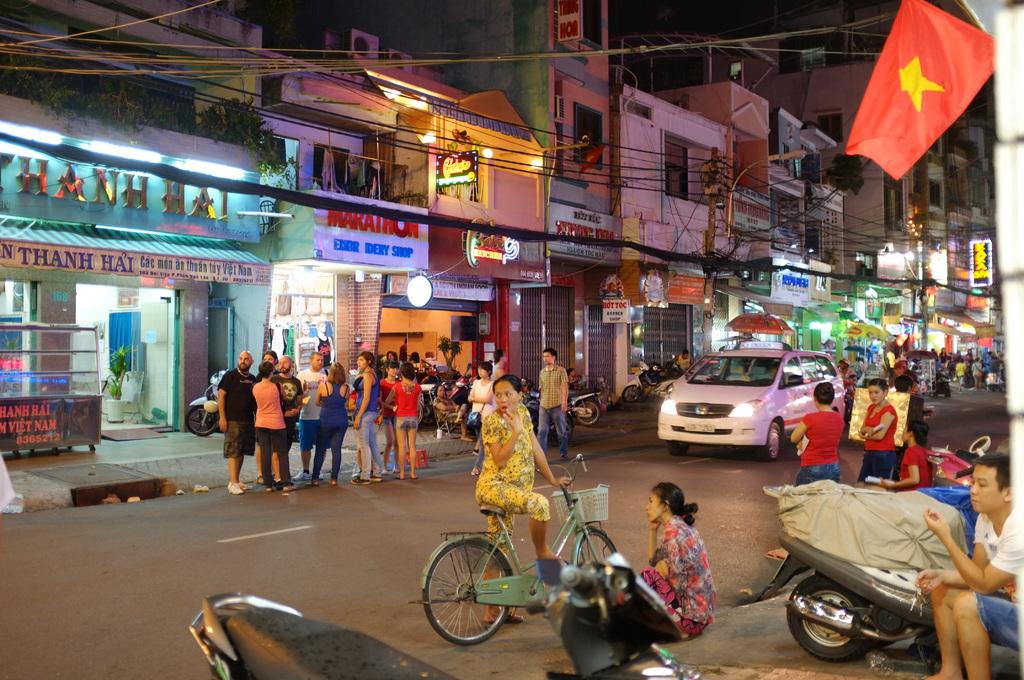What is the country named on the black banner on the left side of the image?
Make the answer very short. Vietnam. 